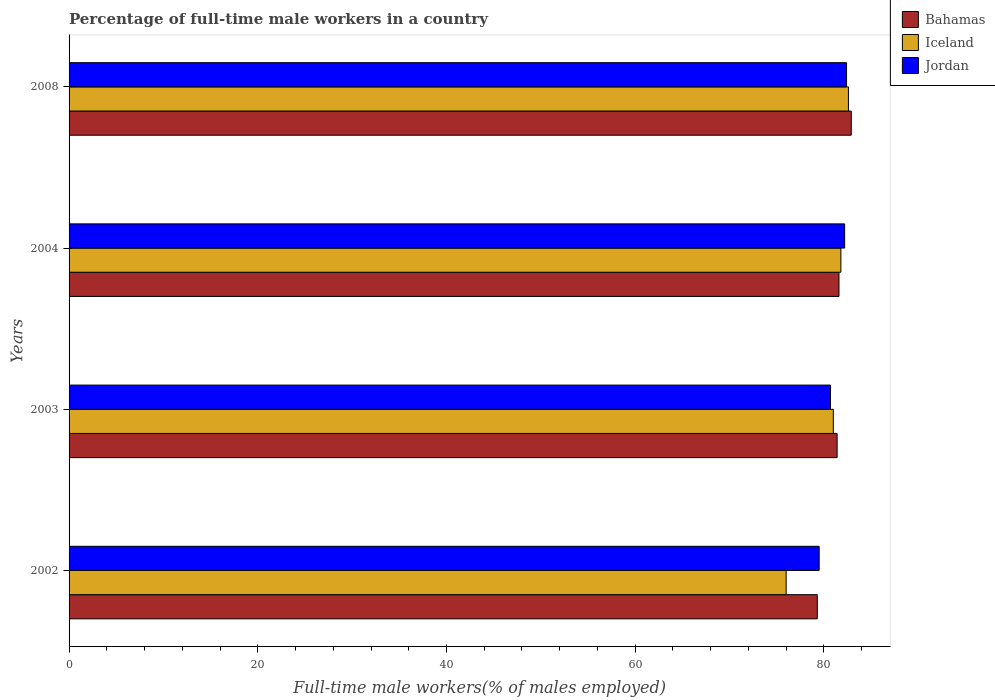How many groups of bars are there?
Provide a succinct answer. 4. Are the number of bars on each tick of the Y-axis equal?
Offer a terse response. Yes. What is the percentage of full-time male workers in Jordan in 2003?
Provide a short and direct response. 80.7. Across all years, what is the maximum percentage of full-time male workers in Iceland?
Provide a succinct answer. 82.6. In which year was the percentage of full-time male workers in Bahamas minimum?
Offer a very short reply. 2002. What is the total percentage of full-time male workers in Bahamas in the graph?
Provide a short and direct response. 325.2. What is the difference between the percentage of full-time male workers in Jordan in 2002 and that in 2003?
Your response must be concise. -1.2. What is the difference between the percentage of full-time male workers in Jordan in 2003 and the percentage of full-time male workers in Iceland in 2002?
Give a very brief answer. 4.7. What is the average percentage of full-time male workers in Iceland per year?
Your answer should be compact. 80.35. In the year 2003, what is the difference between the percentage of full-time male workers in Jordan and percentage of full-time male workers in Bahamas?
Provide a short and direct response. -0.7. What is the ratio of the percentage of full-time male workers in Iceland in 2004 to that in 2008?
Ensure brevity in your answer.  0.99. Is the percentage of full-time male workers in Iceland in 2002 less than that in 2004?
Your response must be concise. Yes. Is the difference between the percentage of full-time male workers in Jordan in 2004 and 2008 greater than the difference between the percentage of full-time male workers in Bahamas in 2004 and 2008?
Your response must be concise. Yes. What is the difference between the highest and the second highest percentage of full-time male workers in Bahamas?
Ensure brevity in your answer.  1.3. What is the difference between the highest and the lowest percentage of full-time male workers in Jordan?
Keep it short and to the point. 2.9. Is the sum of the percentage of full-time male workers in Jordan in 2003 and 2004 greater than the maximum percentage of full-time male workers in Bahamas across all years?
Give a very brief answer. Yes. What does the 1st bar from the bottom in 2008 represents?
Your answer should be compact. Bahamas. Is it the case that in every year, the sum of the percentage of full-time male workers in Jordan and percentage of full-time male workers in Iceland is greater than the percentage of full-time male workers in Bahamas?
Your answer should be compact. Yes. How many bars are there?
Give a very brief answer. 12. Are all the bars in the graph horizontal?
Your response must be concise. Yes. How many years are there in the graph?
Ensure brevity in your answer.  4. What is the difference between two consecutive major ticks on the X-axis?
Keep it short and to the point. 20. Are the values on the major ticks of X-axis written in scientific E-notation?
Your answer should be compact. No. Does the graph contain grids?
Give a very brief answer. No. Where does the legend appear in the graph?
Your response must be concise. Top right. How are the legend labels stacked?
Your response must be concise. Vertical. What is the title of the graph?
Your answer should be very brief. Percentage of full-time male workers in a country. What is the label or title of the X-axis?
Provide a succinct answer. Full-time male workers(% of males employed). What is the Full-time male workers(% of males employed) of Bahamas in 2002?
Your answer should be very brief. 79.3. What is the Full-time male workers(% of males employed) of Jordan in 2002?
Ensure brevity in your answer.  79.5. What is the Full-time male workers(% of males employed) of Bahamas in 2003?
Offer a very short reply. 81.4. What is the Full-time male workers(% of males employed) of Iceland in 2003?
Your response must be concise. 81. What is the Full-time male workers(% of males employed) of Jordan in 2003?
Provide a succinct answer. 80.7. What is the Full-time male workers(% of males employed) in Bahamas in 2004?
Offer a terse response. 81.6. What is the Full-time male workers(% of males employed) of Iceland in 2004?
Offer a very short reply. 81.8. What is the Full-time male workers(% of males employed) in Jordan in 2004?
Provide a succinct answer. 82.2. What is the Full-time male workers(% of males employed) of Bahamas in 2008?
Make the answer very short. 82.9. What is the Full-time male workers(% of males employed) of Iceland in 2008?
Your response must be concise. 82.6. What is the Full-time male workers(% of males employed) of Jordan in 2008?
Make the answer very short. 82.4. Across all years, what is the maximum Full-time male workers(% of males employed) of Bahamas?
Offer a terse response. 82.9. Across all years, what is the maximum Full-time male workers(% of males employed) in Iceland?
Offer a terse response. 82.6. Across all years, what is the maximum Full-time male workers(% of males employed) in Jordan?
Give a very brief answer. 82.4. Across all years, what is the minimum Full-time male workers(% of males employed) of Bahamas?
Give a very brief answer. 79.3. Across all years, what is the minimum Full-time male workers(% of males employed) in Jordan?
Provide a succinct answer. 79.5. What is the total Full-time male workers(% of males employed) of Bahamas in the graph?
Offer a very short reply. 325.2. What is the total Full-time male workers(% of males employed) of Iceland in the graph?
Your answer should be very brief. 321.4. What is the total Full-time male workers(% of males employed) in Jordan in the graph?
Your answer should be compact. 324.8. What is the difference between the Full-time male workers(% of males employed) of Iceland in 2002 and that in 2003?
Offer a terse response. -5. What is the difference between the Full-time male workers(% of males employed) of Jordan in 2002 and that in 2003?
Make the answer very short. -1.2. What is the difference between the Full-time male workers(% of males employed) of Bahamas in 2002 and that in 2004?
Offer a very short reply. -2.3. What is the difference between the Full-time male workers(% of males employed) of Iceland in 2002 and that in 2004?
Keep it short and to the point. -5.8. What is the difference between the Full-time male workers(% of males employed) of Bahamas in 2002 and that in 2008?
Your answer should be compact. -3.6. What is the difference between the Full-time male workers(% of males employed) of Iceland in 2002 and that in 2008?
Keep it short and to the point. -6.6. What is the difference between the Full-time male workers(% of males employed) in Jordan in 2003 and that in 2004?
Provide a succinct answer. -1.5. What is the difference between the Full-time male workers(% of males employed) in Iceland in 2003 and that in 2008?
Ensure brevity in your answer.  -1.6. What is the difference between the Full-time male workers(% of males employed) in Jordan in 2003 and that in 2008?
Offer a terse response. -1.7. What is the difference between the Full-time male workers(% of males employed) in Bahamas in 2002 and the Full-time male workers(% of males employed) in Iceland in 2003?
Provide a short and direct response. -1.7. What is the difference between the Full-time male workers(% of males employed) in Iceland in 2002 and the Full-time male workers(% of males employed) in Jordan in 2003?
Your answer should be very brief. -4.7. What is the difference between the Full-time male workers(% of males employed) in Bahamas in 2002 and the Full-time male workers(% of males employed) in Jordan in 2004?
Your response must be concise. -2.9. What is the difference between the Full-time male workers(% of males employed) of Bahamas in 2002 and the Full-time male workers(% of males employed) of Iceland in 2008?
Offer a terse response. -3.3. What is the difference between the Full-time male workers(% of males employed) of Bahamas in 2002 and the Full-time male workers(% of males employed) of Jordan in 2008?
Your response must be concise. -3.1. What is the difference between the Full-time male workers(% of males employed) of Bahamas in 2003 and the Full-time male workers(% of males employed) of Iceland in 2004?
Provide a succinct answer. -0.4. What is the difference between the Full-time male workers(% of males employed) in Bahamas in 2003 and the Full-time male workers(% of males employed) in Jordan in 2004?
Your answer should be compact. -0.8. What is the difference between the Full-time male workers(% of males employed) of Iceland in 2003 and the Full-time male workers(% of males employed) of Jordan in 2004?
Your answer should be very brief. -1.2. What is the difference between the Full-time male workers(% of males employed) in Bahamas in 2003 and the Full-time male workers(% of males employed) in Jordan in 2008?
Provide a short and direct response. -1. What is the difference between the Full-time male workers(% of males employed) of Iceland in 2003 and the Full-time male workers(% of males employed) of Jordan in 2008?
Your answer should be compact. -1.4. What is the difference between the Full-time male workers(% of males employed) in Bahamas in 2004 and the Full-time male workers(% of males employed) in Jordan in 2008?
Keep it short and to the point. -0.8. What is the difference between the Full-time male workers(% of males employed) of Iceland in 2004 and the Full-time male workers(% of males employed) of Jordan in 2008?
Your answer should be compact. -0.6. What is the average Full-time male workers(% of males employed) of Bahamas per year?
Offer a terse response. 81.3. What is the average Full-time male workers(% of males employed) in Iceland per year?
Your response must be concise. 80.35. What is the average Full-time male workers(% of males employed) in Jordan per year?
Your answer should be very brief. 81.2. In the year 2002, what is the difference between the Full-time male workers(% of males employed) in Bahamas and Full-time male workers(% of males employed) in Iceland?
Your answer should be compact. 3.3. In the year 2002, what is the difference between the Full-time male workers(% of males employed) of Iceland and Full-time male workers(% of males employed) of Jordan?
Offer a terse response. -3.5. In the year 2003, what is the difference between the Full-time male workers(% of males employed) of Bahamas and Full-time male workers(% of males employed) of Jordan?
Give a very brief answer. 0.7. In the year 2008, what is the difference between the Full-time male workers(% of males employed) in Bahamas and Full-time male workers(% of males employed) in Iceland?
Provide a succinct answer. 0.3. In the year 2008, what is the difference between the Full-time male workers(% of males employed) in Bahamas and Full-time male workers(% of males employed) in Jordan?
Your answer should be very brief. 0.5. What is the ratio of the Full-time male workers(% of males employed) of Bahamas in 2002 to that in 2003?
Your answer should be very brief. 0.97. What is the ratio of the Full-time male workers(% of males employed) of Iceland in 2002 to that in 2003?
Provide a short and direct response. 0.94. What is the ratio of the Full-time male workers(% of males employed) in Jordan in 2002 to that in 2003?
Give a very brief answer. 0.99. What is the ratio of the Full-time male workers(% of males employed) of Bahamas in 2002 to that in 2004?
Offer a very short reply. 0.97. What is the ratio of the Full-time male workers(% of males employed) in Iceland in 2002 to that in 2004?
Provide a short and direct response. 0.93. What is the ratio of the Full-time male workers(% of males employed) in Jordan in 2002 to that in 2004?
Your answer should be compact. 0.97. What is the ratio of the Full-time male workers(% of males employed) of Bahamas in 2002 to that in 2008?
Give a very brief answer. 0.96. What is the ratio of the Full-time male workers(% of males employed) in Iceland in 2002 to that in 2008?
Ensure brevity in your answer.  0.92. What is the ratio of the Full-time male workers(% of males employed) in Jordan in 2002 to that in 2008?
Your answer should be very brief. 0.96. What is the ratio of the Full-time male workers(% of males employed) in Bahamas in 2003 to that in 2004?
Your answer should be compact. 1. What is the ratio of the Full-time male workers(% of males employed) in Iceland in 2003 to that in 2004?
Your answer should be compact. 0.99. What is the ratio of the Full-time male workers(% of males employed) in Jordan in 2003 to that in 2004?
Offer a terse response. 0.98. What is the ratio of the Full-time male workers(% of males employed) in Bahamas in 2003 to that in 2008?
Give a very brief answer. 0.98. What is the ratio of the Full-time male workers(% of males employed) in Iceland in 2003 to that in 2008?
Ensure brevity in your answer.  0.98. What is the ratio of the Full-time male workers(% of males employed) in Jordan in 2003 to that in 2008?
Keep it short and to the point. 0.98. What is the ratio of the Full-time male workers(% of males employed) in Bahamas in 2004 to that in 2008?
Offer a very short reply. 0.98. What is the ratio of the Full-time male workers(% of males employed) of Iceland in 2004 to that in 2008?
Keep it short and to the point. 0.99. What is the difference between the highest and the lowest Full-time male workers(% of males employed) in Iceland?
Your answer should be compact. 6.6. 